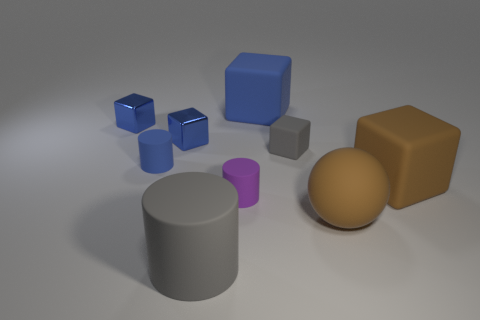What shape is the rubber object that is behind the tiny gray block?
Your answer should be very brief. Cube. There is a large thing that is the same color as the small rubber cube; what shape is it?
Make the answer very short. Cylinder. What number of blue cubes have the same size as the blue matte cylinder?
Your answer should be very brief. 2. The matte ball has what color?
Offer a very short reply. Brown. There is a large matte sphere; does it have the same color as the block that is to the right of the small gray matte object?
Ensure brevity in your answer.  Yes. What is the size of the blue block that is the same material as the blue cylinder?
Provide a succinct answer. Large. Is there another big ball of the same color as the sphere?
Your response must be concise. No. How many things are either matte things behind the small matte cube or gray matte objects?
Keep it short and to the point. 3. Is the material of the tiny blue cylinder the same as the gray object that is right of the big cylinder?
Ensure brevity in your answer.  Yes. What size is the object that is the same color as the large rubber cylinder?
Provide a short and direct response. Small. 